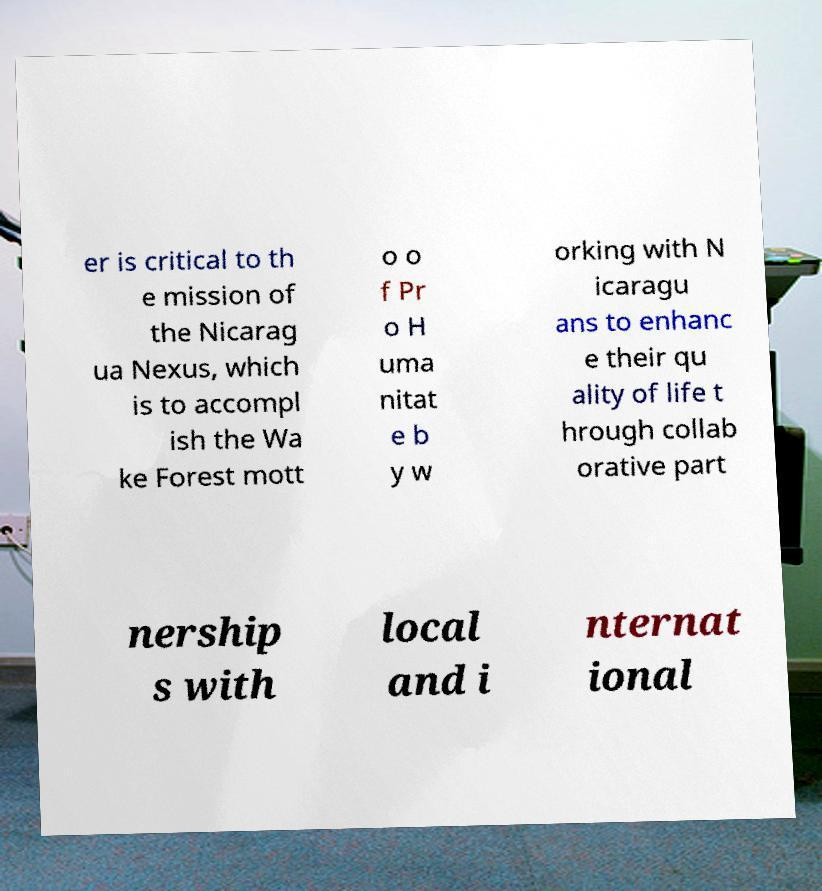Can you accurately transcribe the text from the provided image for me? er is critical to th e mission of the Nicarag ua Nexus, which is to accompl ish the Wa ke Forest mott o o f Pr o H uma nitat e b y w orking with N icaragu ans to enhanc e their qu ality of life t hrough collab orative part nership s with local and i nternat ional 